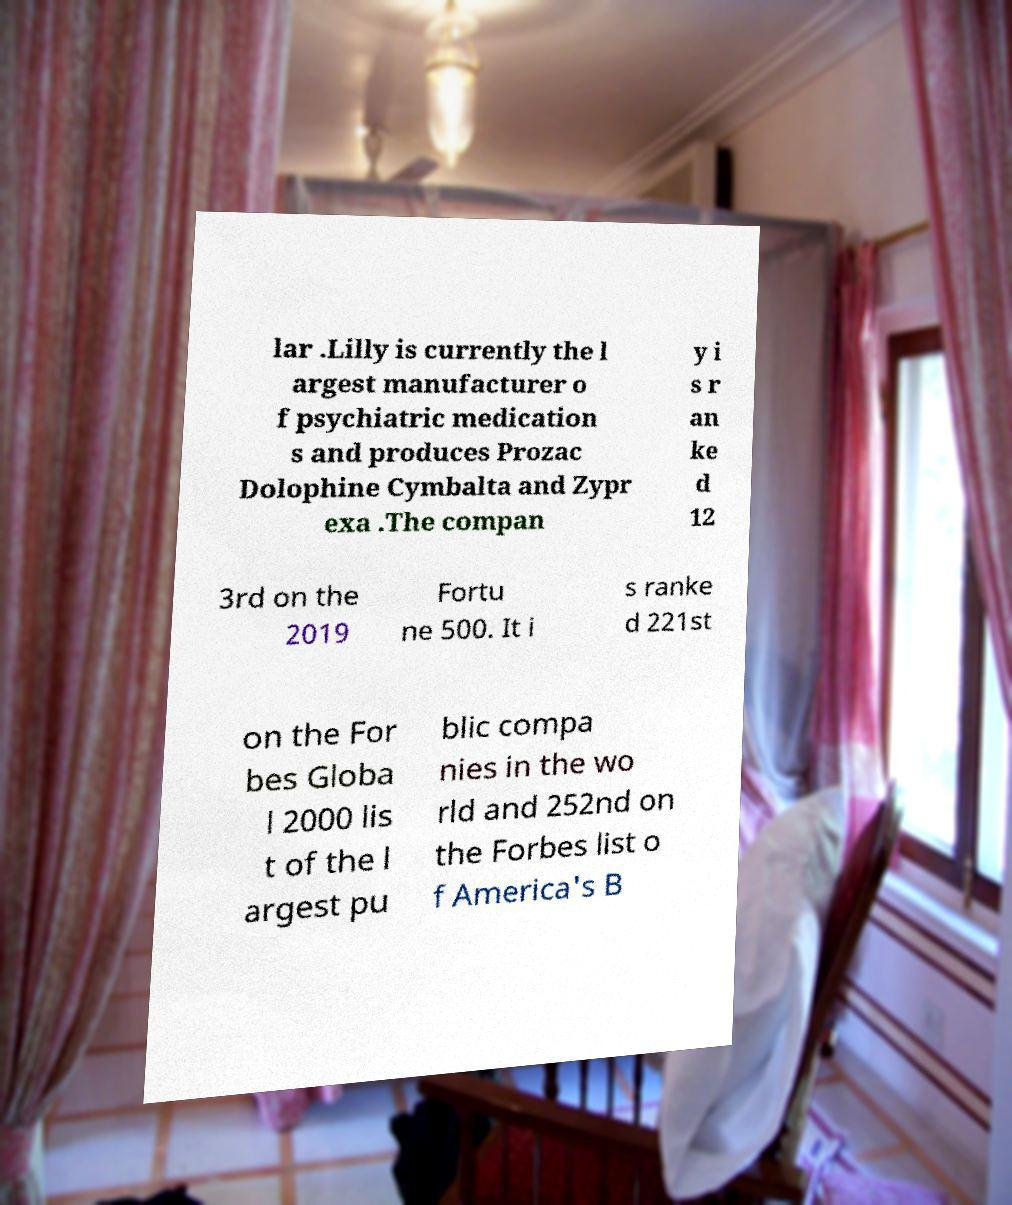Could you extract and type out the text from this image? lar .Lilly is currently the l argest manufacturer o f psychiatric medication s and produces Prozac Dolophine Cymbalta and Zypr exa .The compan y i s r an ke d 12 3rd on the 2019 Fortu ne 500. It i s ranke d 221st on the For bes Globa l 2000 lis t of the l argest pu blic compa nies in the wo rld and 252nd on the Forbes list o f America's B 